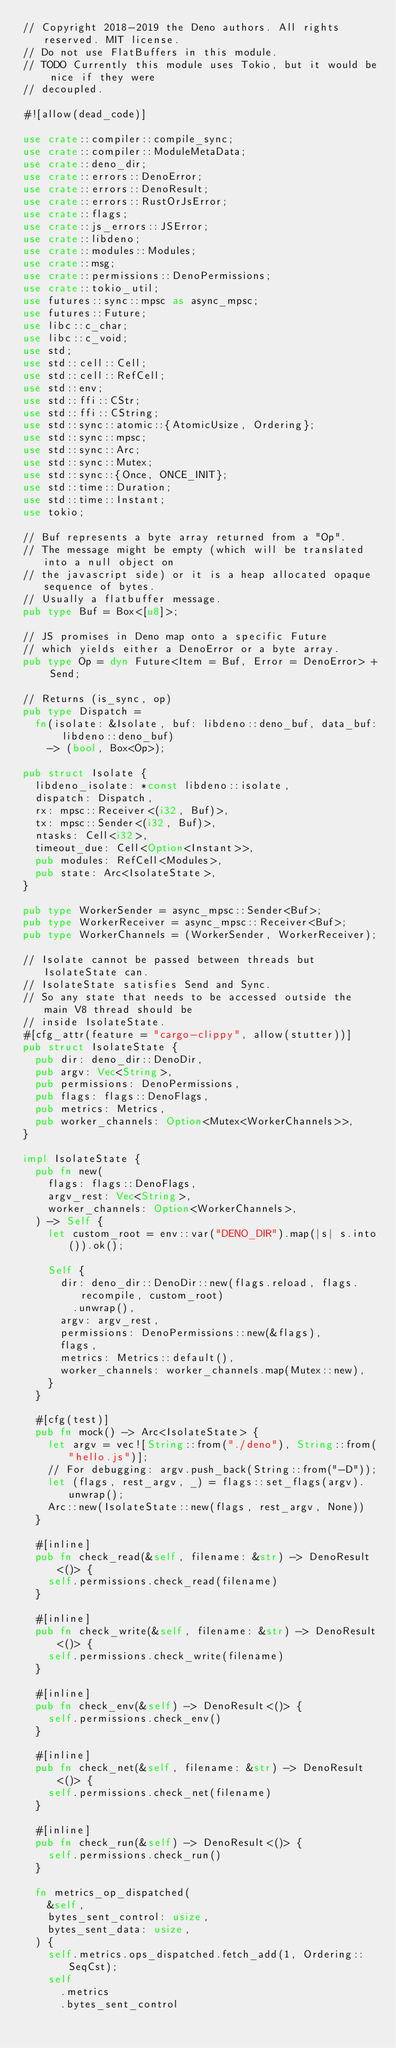Convert code to text. <code><loc_0><loc_0><loc_500><loc_500><_Rust_>// Copyright 2018-2019 the Deno authors. All rights reserved. MIT license.
// Do not use FlatBuffers in this module.
// TODO Currently this module uses Tokio, but it would be nice if they were
// decoupled.

#![allow(dead_code)]

use crate::compiler::compile_sync;
use crate::compiler::ModuleMetaData;
use crate::deno_dir;
use crate::errors::DenoError;
use crate::errors::DenoResult;
use crate::errors::RustOrJsError;
use crate::flags;
use crate::js_errors::JSError;
use crate::libdeno;
use crate::modules::Modules;
use crate::msg;
use crate::permissions::DenoPermissions;
use crate::tokio_util;
use futures::sync::mpsc as async_mpsc;
use futures::Future;
use libc::c_char;
use libc::c_void;
use std;
use std::cell::Cell;
use std::cell::RefCell;
use std::env;
use std::ffi::CStr;
use std::ffi::CString;
use std::sync::atomic::{AtomicUsize, Ordering};
use std::sync::mpsc;
use std::sync::Arc;
use std::sync::Mutex;
use std::sync::{Once, ONCE_INIT};
use std::time::Duration;
use std::time::Instant;
use tokio;

// Buf represents a byte array returned from a "Op".
// The message might be empty (which will be translated into a null object on
// the javascript side) or it is a heap allocated opaque sequence of bytes.
// Usually a flatbuffer message.
pub type Buf = Box<[u8]>;

// JS promises in Deno map onto a specific Future
// which yields either a DenoError or a byte array.
pub type Op = dyn Future<Item = Buf, Error = DenoError> + Send;

// Returns (is_sync, op)
pub type Dispatch =
  fn(isolate: &Isolate, buf: libdeno::deno_buf, data_buf: libdeno::deno_buf)
    -> (bool, Box<Op>);

pub struct Isolate {
  libdeno_isolate: *const libdeno::isolate,
  dispatch: Dispatch,
  rx: mpsc::Receiver<(i32, Buf)>,
  tx: mpsc::Sender<(i32, Buf)>,
  ntasks: Cell<i32>,
  timeout_due: Cell<Option<Instant>>,
  pub modules: RefCell<Modules>,
  pub state: Arc<IsolateState>,
}

pub type WorkerSender = async_mpsc::Sender<Buf>;
pub type WorkerReceiver = async_mpsc::Receiver<Buf>;
pub type WorkerChannels = (WorkerSender, WorkerReceiver);

// Isolate cannot be passed between threads but IsolateState can.
// IsolateState satisfies Send and Sync.
// So any state that needs to be accessed outside the main V8 thread should be
// inside IsolateState.
#[cfg_attr(feature = "cargo-clippy", allow(stutter))]
pub struct IsolateState {
  pub dir: deno_dir::DenoDir,
  pub argv: Vec<String>,
  pub permissions: DenoPermissions,
  pub flags: flags::DenoFlags,
  pub metrics: Metrics,
  pub worker_channels: Option<Mutex<WorkerChannels>>,
}

impl IsolateState {
  pub fn new(
    flags: flags::DenoFlags,
    argv_rest: Vec<String>,
    worker_channels: Option<WorkerChannels>,
  ) -> Self {
    let custom_root = env::var("DENO_DIR").map(|s| s.into()).ok();

    Self {
      dir: deno_dir::DenoDir::new(flags.reload, flags.recompile, custom_root)
        .unwrap(),
      argv: argv_rest,
      permissions: DenoPermissions::new(&flags),
      flags,
      metrics: Metrics::default(),
      worker_channels: worker_channels.map(Mutex::new),
    }
  }

  #[cfg(test)]
  pub fn mock() -> Arc<IsolateState> {
    let argv = vec![String::from("./deno"), String::from("hello.js")];
    // For debugging: argv.push_back(String::from("-D"));
    let (flags, rest_argv, _) = flags::set_flags(argv).unwrap();
    Arc::new(IsolateState::new(flags, rest_argv, None))
  }

  #[inline]
  pub fn check_read(&self, filename: &str) -> DenoResult<()> {
    self.permissions.check_read(filename)
  }

  #[inline]
  pub fn check_write(&self, filename: &str) -> DenoResult<()> {
    self.permissions.check_write(filename)
  }

  #[inline]
  pub fn check_env(&self) -> DenoResult<()> {
    self.permissions.check_env()
  }

  #[inline]
  pub fn check_net(&self, filename: &str) -> DenoResult<()> {
    self.permissions.check_net(filename)
  }

  #[inline]
  pub fn check_run(&self) -> DenoResult<()> {
    self.permissions.check_run()
  }

  fn metrics_op_dispatched(
    &self,
    bytes_sent_control: usize,
    bytes_sent_data: usize,
  ) {
    self.metrics.ops_dispatched.fetch_add(1, Ordering::SeqCst);
    self
      .metrics
      .bytes_sent_control</code> 